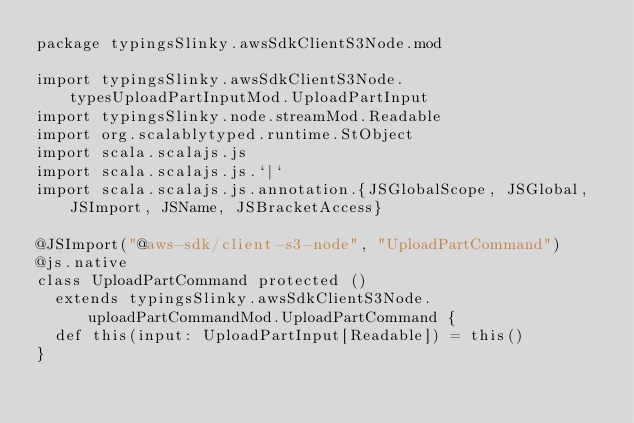<code> <loc_0><loc_0><loc_500><loc_500><_Scala_>package typingsSlinky.awsSdkClientS3Node.mod

import typingsSlinky.awsSdkClientS3Node.typesUploadPartInputMod.UploadPartInput
import typingsSlinky.node.streamMod.Readable
import org.scalablytyped.runtime.StObject
import scala.scalajs.js
import scala.scalajs.js.`|`
import scala.scalajs.js.annotation.{JSGlobalScope, JSGlobal, JSImport, JSName, JSBracketAccess}

@JSImport("@aws-sdk/client-s3-node", "UploadPartCommand")
@js.native
class UploadPartCommand protected ()
  extends typingsSlinky.awsSdkClientS3Node.uploadPartCommandMod.UploadPartCommand {
  def this(input: UploadPartInput[Readable]) = this()
}
</code> 